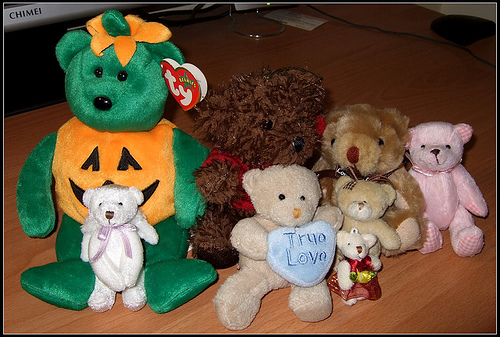Please identify all text content in this image. CHIMEI ty True Love 